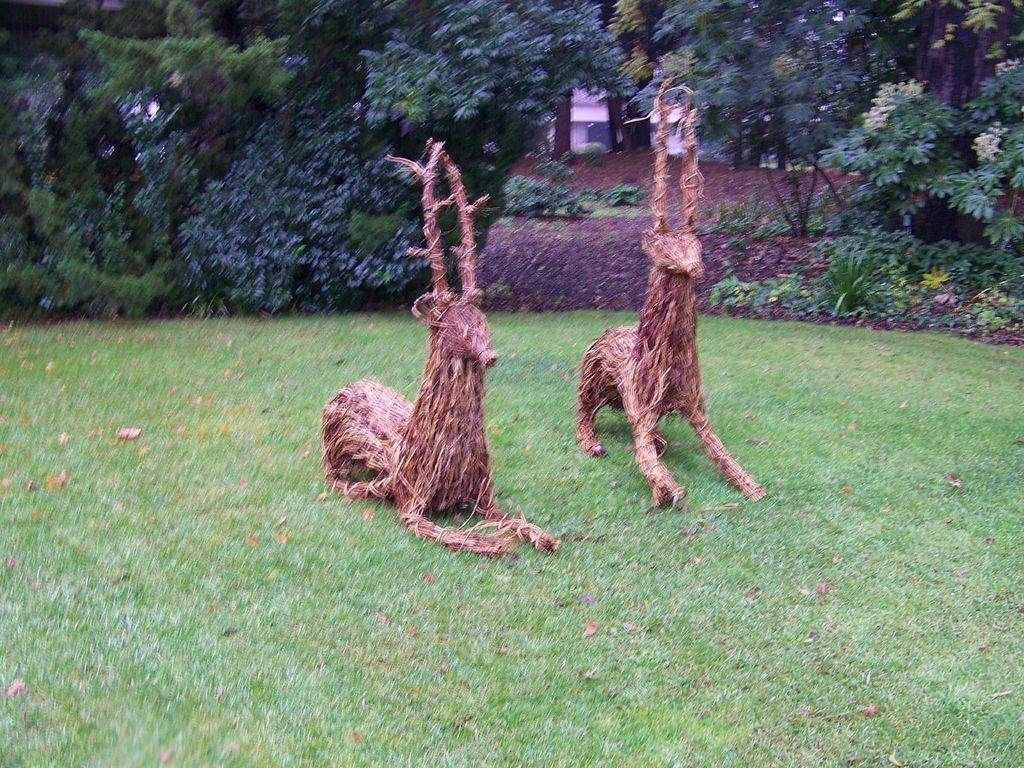In one or two sentences, can you explain what this image depicts? In this picture we can see sculptures and dried leaves on the grass and in the background we can see trees, plants, building. 